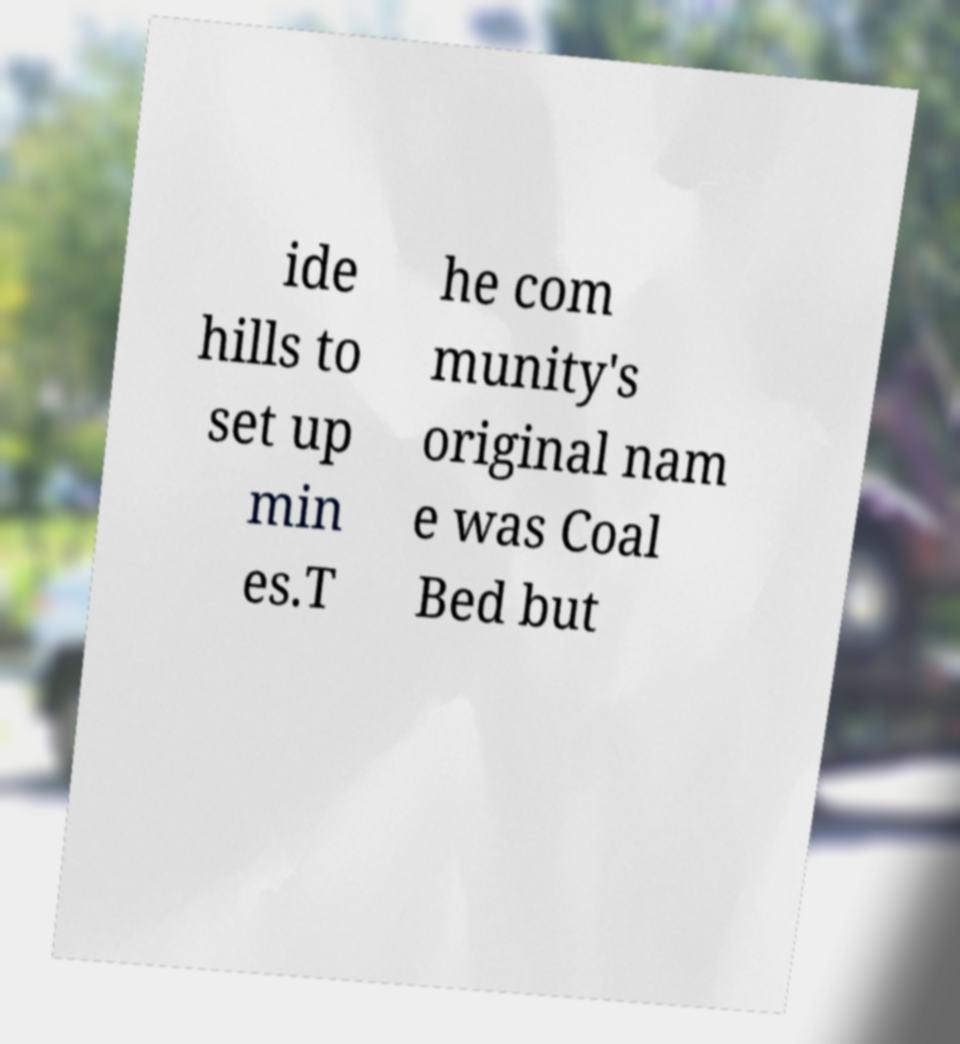Please read and relay the text visible in this image. What does it say? ide hills to set up min es.T he com munity's original nam e was Coal Bed but 